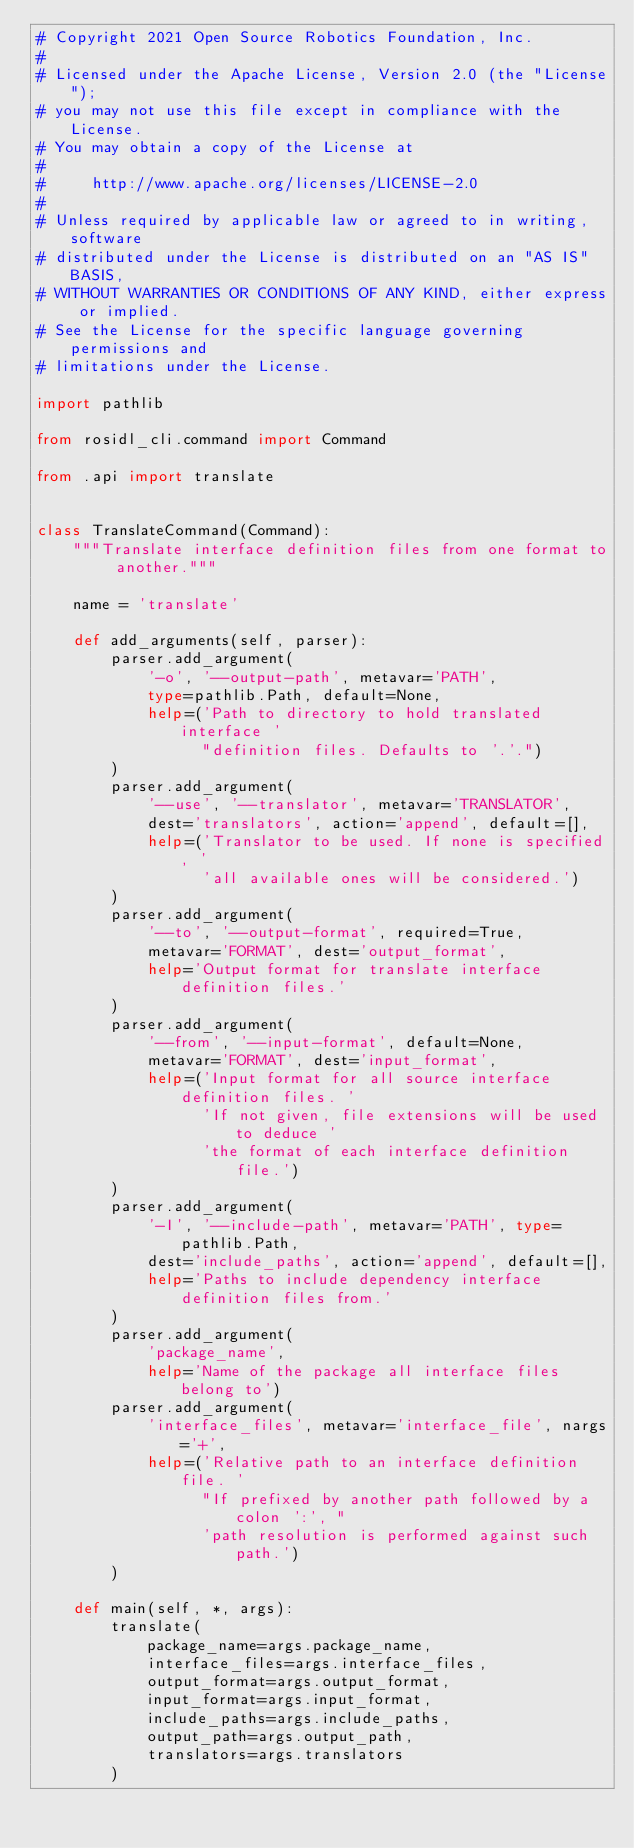Convert code to text. <code><loc_0><loc_0><loc_500><loc_500><_Python_># Copyright 2021 Open Source Robotics Foundation, Inc.
#
# Licensed under the Apache License, Version 2.0 (the "License");
# you may not use this file except in compliance with the License.
# You may obtain a copy of the License at
#
#     http://www.apache.org/licenses/LICENSE-2.0
#
# Unless required by applicable law or agreed to in writing, software
# distributed under the License is distributed on an "AS IS" BASIS,
# WITHOUT WARRANTIES OR CONDITIONS OF ANY KIND, either express or implied.
# See the License for the specific language governing permissions and
# limitations under the License.

import pathlib

from rosidl_cli.command import Command

from .api import translate


class TranslateCommand(Command):
    """Translate interface definition files from one format to another."""

    name = 'translate'

    def add_arguments(self, parser):
        parser.add_argument(
            '-o', '--output-path', metavar='PATH',
            type=pathlib.Path, default=None,
            help=('Path to directory to hold translated interface '
                  "definition files. Defaults to '.'.")
        )
        parser.add_argument(
            '--use', '--translator', metavar='TRANSLATOR',
            dest='translators', action='append', default=[],
            help=('Translator to be used. If none is specified, '
                  'all available ones will be considered.')
        )
        parser.add_argument(
            '--to', '--output-format', required=True,
            metavar='FORMAT', dest='output_format',
            help='Output format for translate interface definition files.'
        )
        parser.add_argument(
            '--from', '--input-format', default=None,
            metavar='FORMAT', dest='input_format',
            help=('Input format for all source interface definition files. '
                  'If not given, file extensions will be used to deduce '
                  'the format of each interface definition file.')
        )
        parser.add_argument(
            '-I', '--include-path', metavar='PATH', type=pathlib.Path,
            dest='include_paths', action='append', default=[],
            help='Paths to include dependency interface definition files from.'
        )
        parser.add_argument(
            'package_name',
            help='Name of the package all interface files belong to')
        parser.add_argument(
            'interface_files', metavar='interface_file', nargs='+',
            help=('Relative path to an interface definition file. '
                  "If prefixed by another path followed by a colon ':', "
                  'path resolution is performed against such path.')
        )

    def main(self, *, args):
        translate(
            package_name=args.package_name,
            interface_files=args.interface_files,
            output_format=args.output_format,
            input_format=args.input_format,
            include_paths=args.include_paths,
            output_path=args.output_path,
            translators=args.translators
        )
</code> 